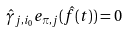<formula> <loc_0><loc_0><loc_500><loc_500>\hat { \gamma } _ { j , i _ { 0 } } e _ { \pi , j } ( \hat { f } ( t ) ) = 0</formula> 